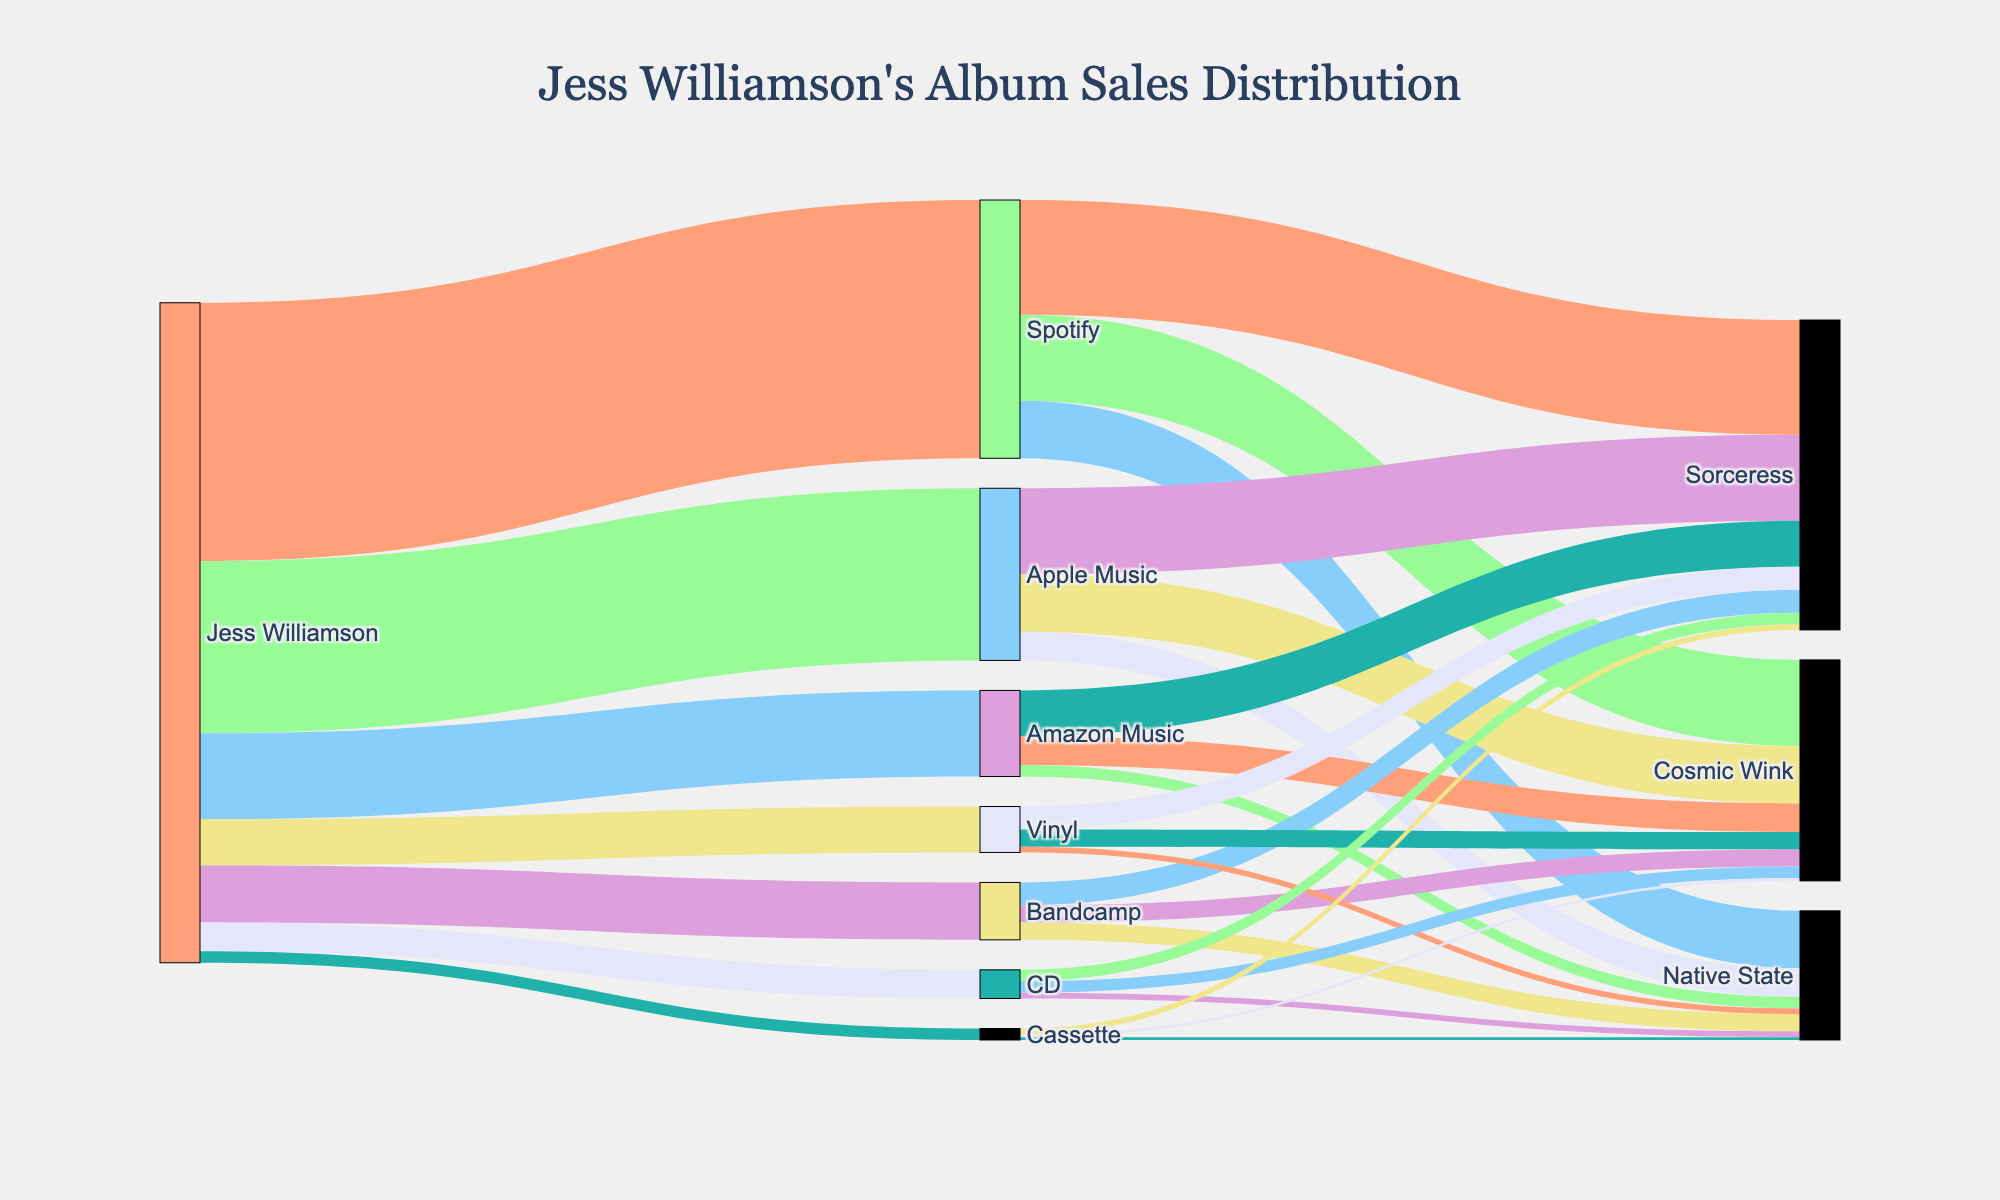what is the main title of the diagram? The main title of the diagram is usually indicated at the top of the figure, providing an overview of what the diagram represents. In this case, the document specifies that the title is "Jess Williamson's Album Sales Distribution."
Answer: Jess Williamson's Album Sales Distribution Which streaming platform has the highest sales for Jess Williamson's albums? To determine this, look at the width of the connections from "Jess Williamson" to each streaming platform. The wider the connection, the higher the sales. In this case, the connection between "Jess Williamson" and "Spotify" is the widest.
Answer: Spotify How many physical formats are shown in the diagram? Identify the nodes that represent physical formats connecting to Jess Williamson. These are "Vinyl," "CD," and "Cassette." Count these nodes to find the total number of physical formats.
Answer: 3 Which album has the lowest sales on Apple Music? Follow the connections from "Apple Music" to the albums. The album with the thinnest connection represents the lowest sales. Here, "Native State" has the thinnest connection from "Apple Music."
Answer: Native State What are the total sales of the album "Cosmic Wink" across all mediums? Locate the connections to "Cosmic Wink" from all mediums and sum the values. This includes sales from "Spotify," "Apple Music," "Amazon Music," "Bandcamp," "Vinyl," "CD," and "Cassette." The sum is 15000 + 10000 + 5000 + 3000 + 3000 + 2000 + 500 = 38500.
Answer: 38500 Which album has the highest sales on Spotify? Observe the connections from "Spotify" to the albums and identify the one with the thickest connection. For Spotify, "Sorceress" has the thickest connection.
Answer: Sorceress Compare the sales of "Sorceress" on Spotify and Apple Music. Which platform has more sales? Follow the connections from "Spotify" and "Apple Music" to "Sorceress." Compare the sales values. On Spotify, it is 20000, and on Apple Music, it is 15000. Thus, Spotify has more sales for "Sorceress."
Answer: Spotify What percentage of total sales does the "Cosmic Wink" album achieve on Bandcamp compared to its total on all platforms? First, find the total sales of "Cosmic Wink" from all platforms (38500). Then, find Bandcamp sales for "Cosmic Wink" (3000). Calculate the percentage as (3000 / 38500) * 100 = approximately 7.79%.
Answer: 7.79% Which album has the least amount of sales on Vinyl? Observe connections from "Vinyl" to the albums. The thinnest connection is to "Native State," indicating it has the least sales on Vinyl.
Answer: Native State How do physical format sales of "Sorceress" compare to digital streaming platform sales? Sum up the sales from physical formats ("Vinyl," "CD," "Cassette") for "Sorceress" which are 4000 + 2000 + 1000 = 7000. For digital streaming platforms ("Spotify," "Apple Music," "Amazon Music," "Bandcamp"), sum them up as 20000 + 15000 + 8000 + 4000 = 47000. Compare the two sums to see that digital streaming platform sales (47000) are significantly higher than physical format sales (7000).
Answer: Digital streaming platform sales are significantly higher than physical format sales 